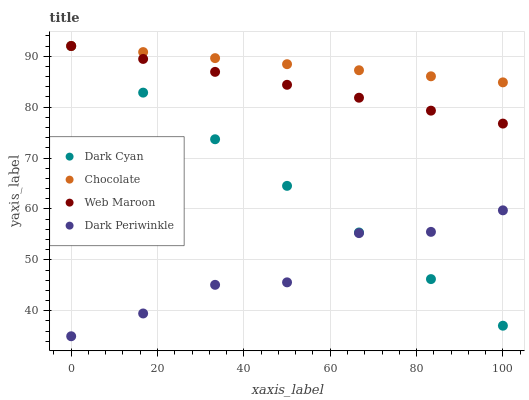Does Dark Periwinkle have the minimum area under the curve?
Answer yes or no. Yes. Does Chocolate have the maximum area under the curve?
Answer yes or no. Yes. Does Web Maroon have the minimum area under the curve?
Answer yes or no. No. Does Web Maroon have the maximum area under the curve?
Answer yes or no. No. Is Chocolate the smoothest?
Answer yes or no. Yes. Is Dark Periwinkle the roughest?
Answer yes or no. Yes. Is Web Maroon the smoothest?
Answer yes or no. No. Is Web Maroon the roughest?
Answer yes or no. No. Does Dark Periwinkle have the lowest value?
Answer yes or no. Yes. Does Web Maroon have the lowest value?
Answer yes or no. No. Does Chocolate have the highest value?
Answer yes or no. Yes. Does Dark Periwinkle have the highest value?
Answer yes or no. No. Is Dark Periwinkle less than Web Maroon?
Answer yes or no. Yes. Is Chocolate greater than Dark Periwinkle?
Answer yes or no. Yes. Does Web Maroon intersect Dark Cyan?
Answer yes or no. Yes. Is Web Maroon less than Dark Cyan?
Answer yes or no. No. Is Web Maroon greater than Dark Cyan?
Answer yes or no. No. Does Dark Periwinkle intersect Web Maroon?
Answer yes or no. No. 